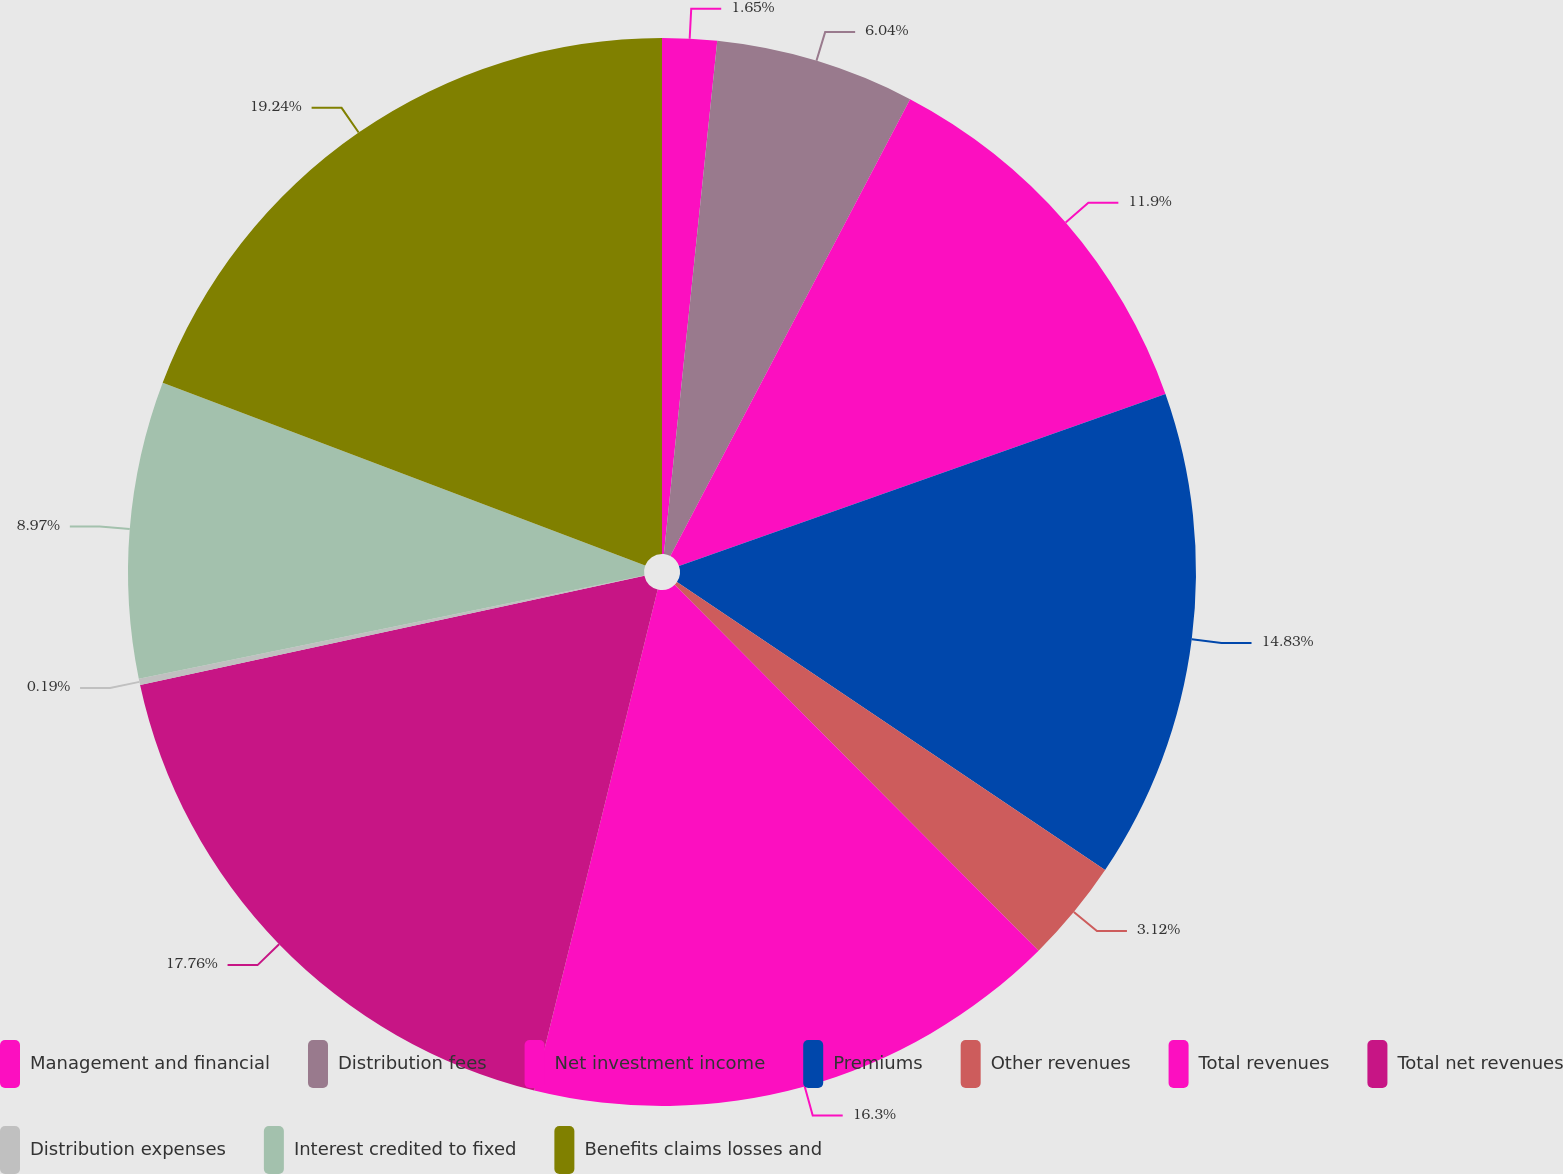<chart> <loc_0><loc_0><loc_500><loc_500><pie_chart><fcel>Management and financial<fcel>Distribution fees<fcel>Net investment income<fcel>Premiums<fcel>Other revenues<fcel>Total revenues<fcel>Total net revenues<fcel>Distribution expenses<fcel>Interest credited to fixed<fcel>Benefits claims losses and<nl><fcel>1.65%<fcel>6.04%<fcel>11.9%<fcel>14.83%<fcel>3.12%<fcel>16.3%<fcel>17.76%<fcel>0.19%<fcel>8.97%<fcel>19.23%<nl></chart> 